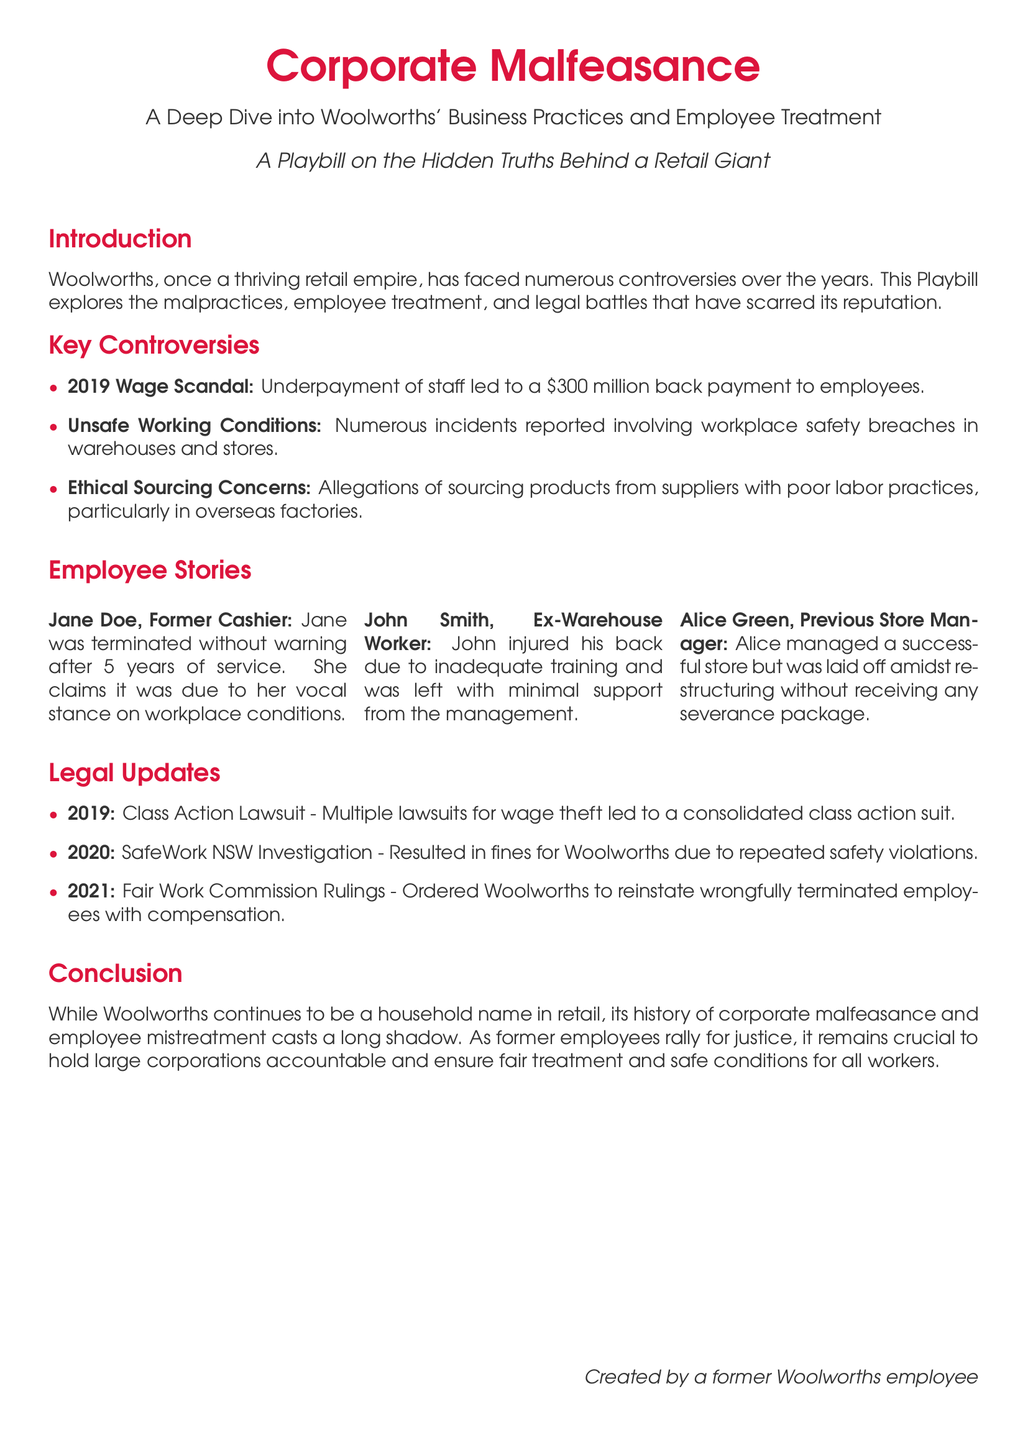What year did the wage scandal occur? The document states that the wage scandal took place in 2019.
Answer: 2019 How much was Woolworths forced to pay employees due to the wage scandal? The document mentions that Woolworths had to pay $300 million back to employees for the wage scandal.
Answer: $300 million What were Woolworths accused of regarding product sourcing? The document indicates that Woolworths faced allegations of sourcing products from suppliers with poor labor practices.
Answer: Poor labor practices Who was terminated without warning after five years of service? According to the document, Jane Doe, a former cashier, was terminated without warning after five years of service.
Answer: Jane Doe What type of lawsuit occurred in 2019? The document states that multiple lawsuits for wage theft resulted in a consolidated class action suit.
Answer: Class Action Lawsuit What safety investigation took place in 2020? The document reveals that SafeWork NSW conducted an investigation in 2020, leading to fines for Woolworths due to safety violations.
Answer: SafeWork NSW Investigation Which former employee injured his back due to inadequate training? The document describes John Smith, an ex-warehouse worker, who injured his back due to inadequate training.
Answer: John Smith Did Alice Green receive a severance package when laid off? The document mentions that Alice Green was laid off without receiving any severance package.
Answer: No What did the Fair Work Commission order Woolworths to do in 2021? The document states that the Fair Work Commission ordered Woolworths to reinstate wrongfully terminated employees with compensation.
Answer: Reinstate and compensate 